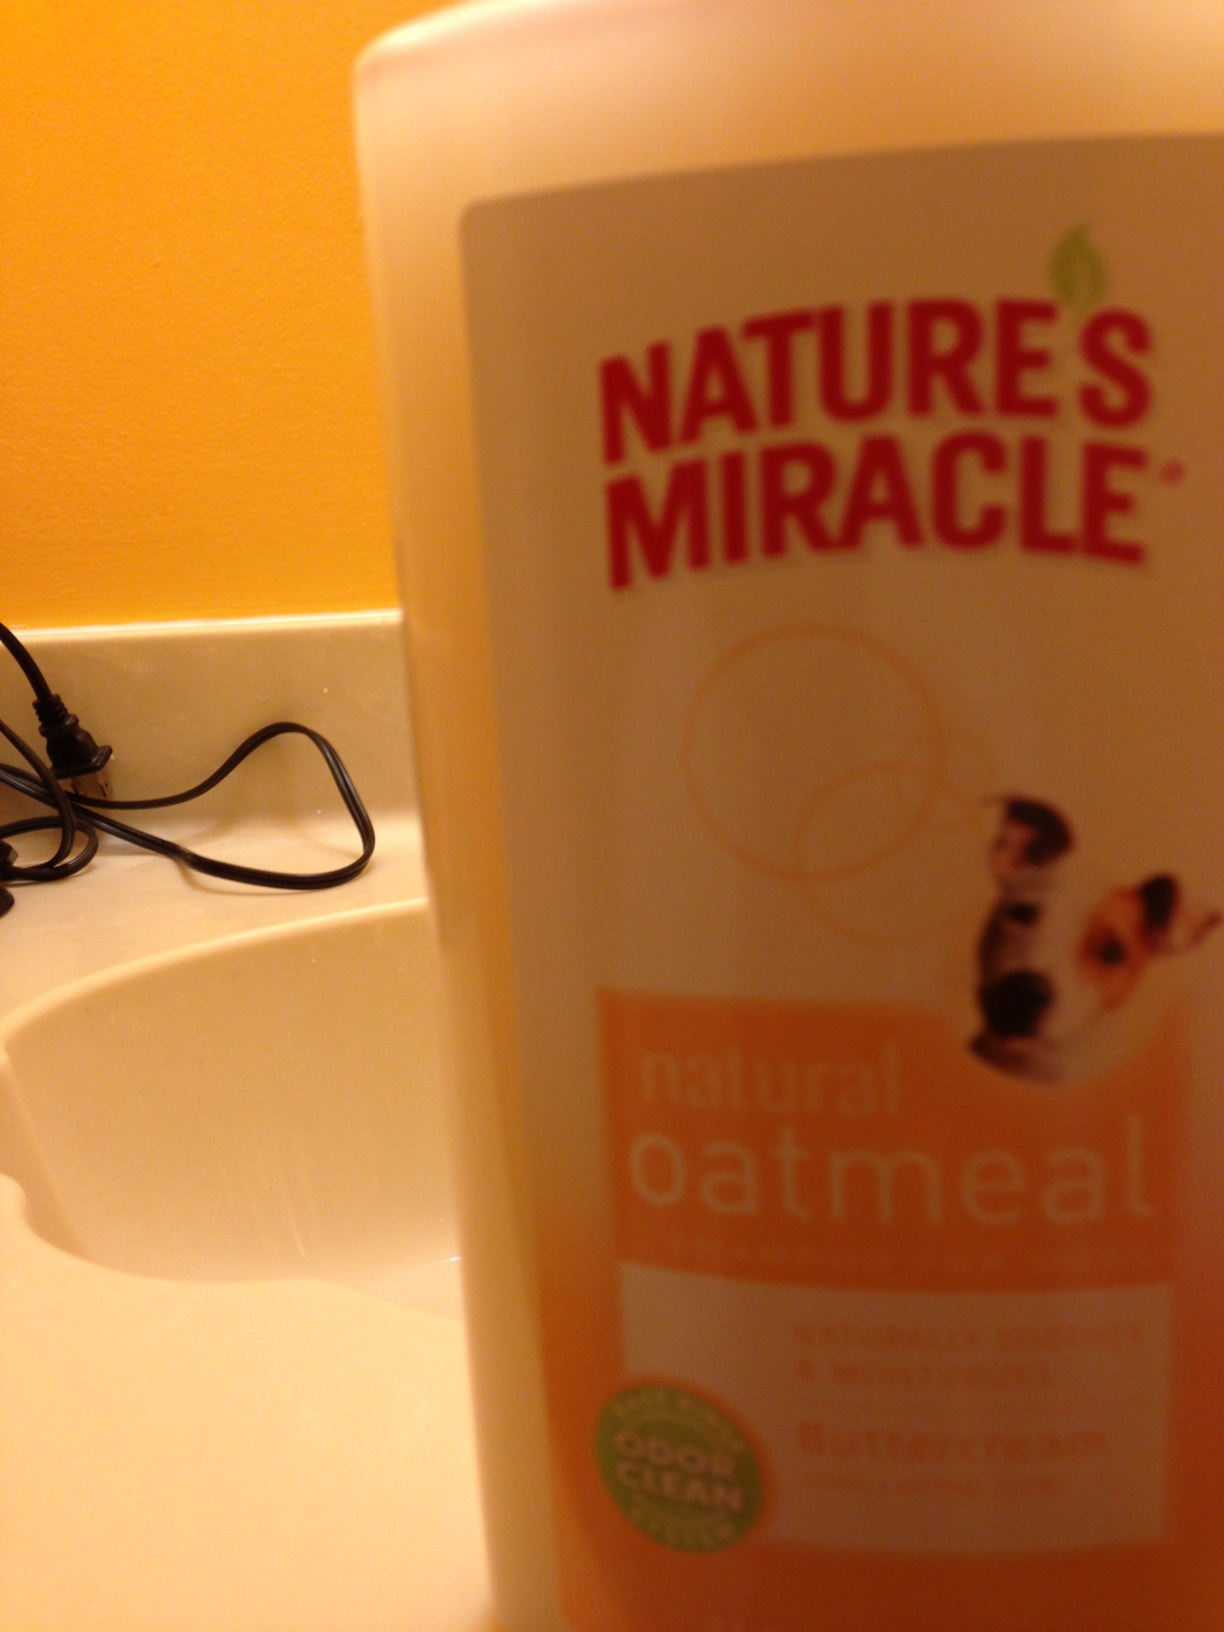What is the name of the product in the picture? from Vizwiz natures miracle dog soap 